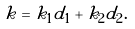Convert formula to latex. <formula><loc_0><loc_0><loc_500><loc_500>k = k _ { 1 } d _ { 1 } + k _ { 2 } d _ { 2 } .</formula> 